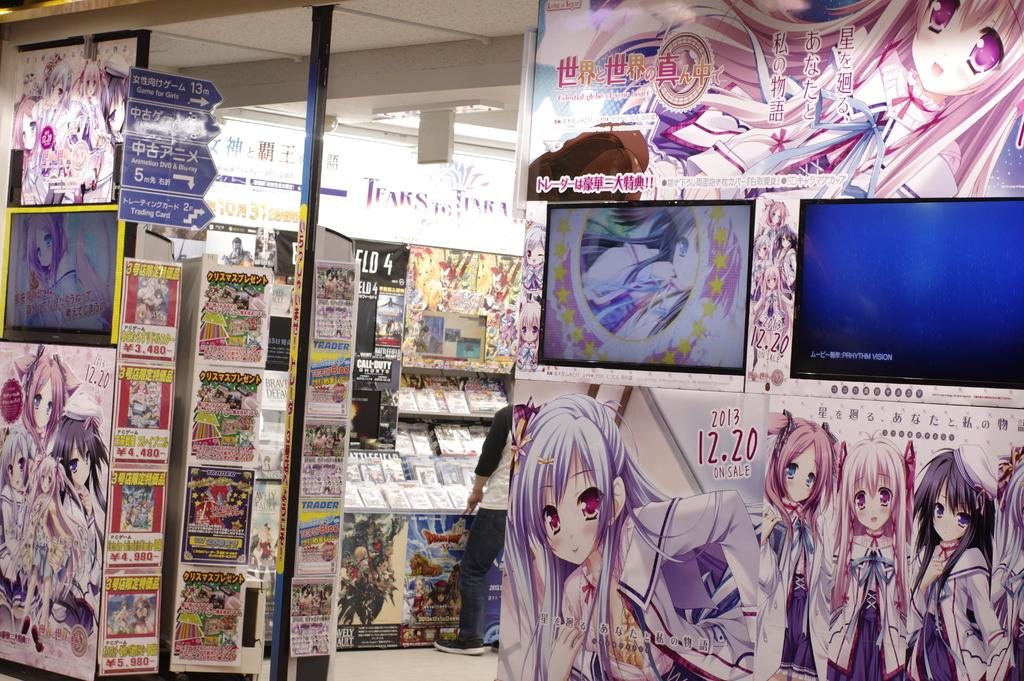What type of images are featured on the posters in the image? A: The posters contain cartoon pictures. What can be seen in the background of the image? There is a rack in the background of the image. What is stored on the rack? There are books in the rack. Who is present in the image? There is a man standing near the rack. How many spiders are crawling on the man's shoulder in the image? There are no spiders present in the image. What is the man's desire in the image? The image does not provide information about the man's desires. 